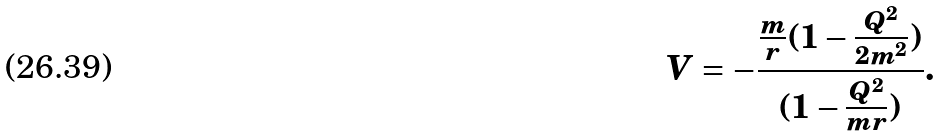Convert formula to latex. <formula><loc_0><loc_0><loc_500><loc_500>V = - \frac { \frac { m } { r } ( 1 - \frac { Q ^ { 2 } } { 2 m ^ { 2 } } ) } { ( 1 - \frac { Q ^ { 2 } } { m r } ) } .</formula> 